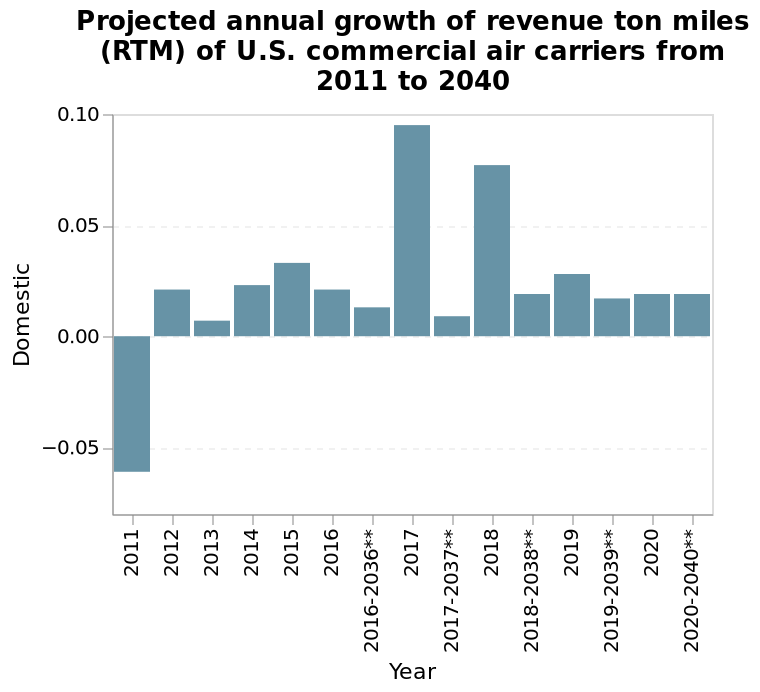<image>
When is the highest projected growth expected?  The highest projected growth is expected in 2017 and 2018. 